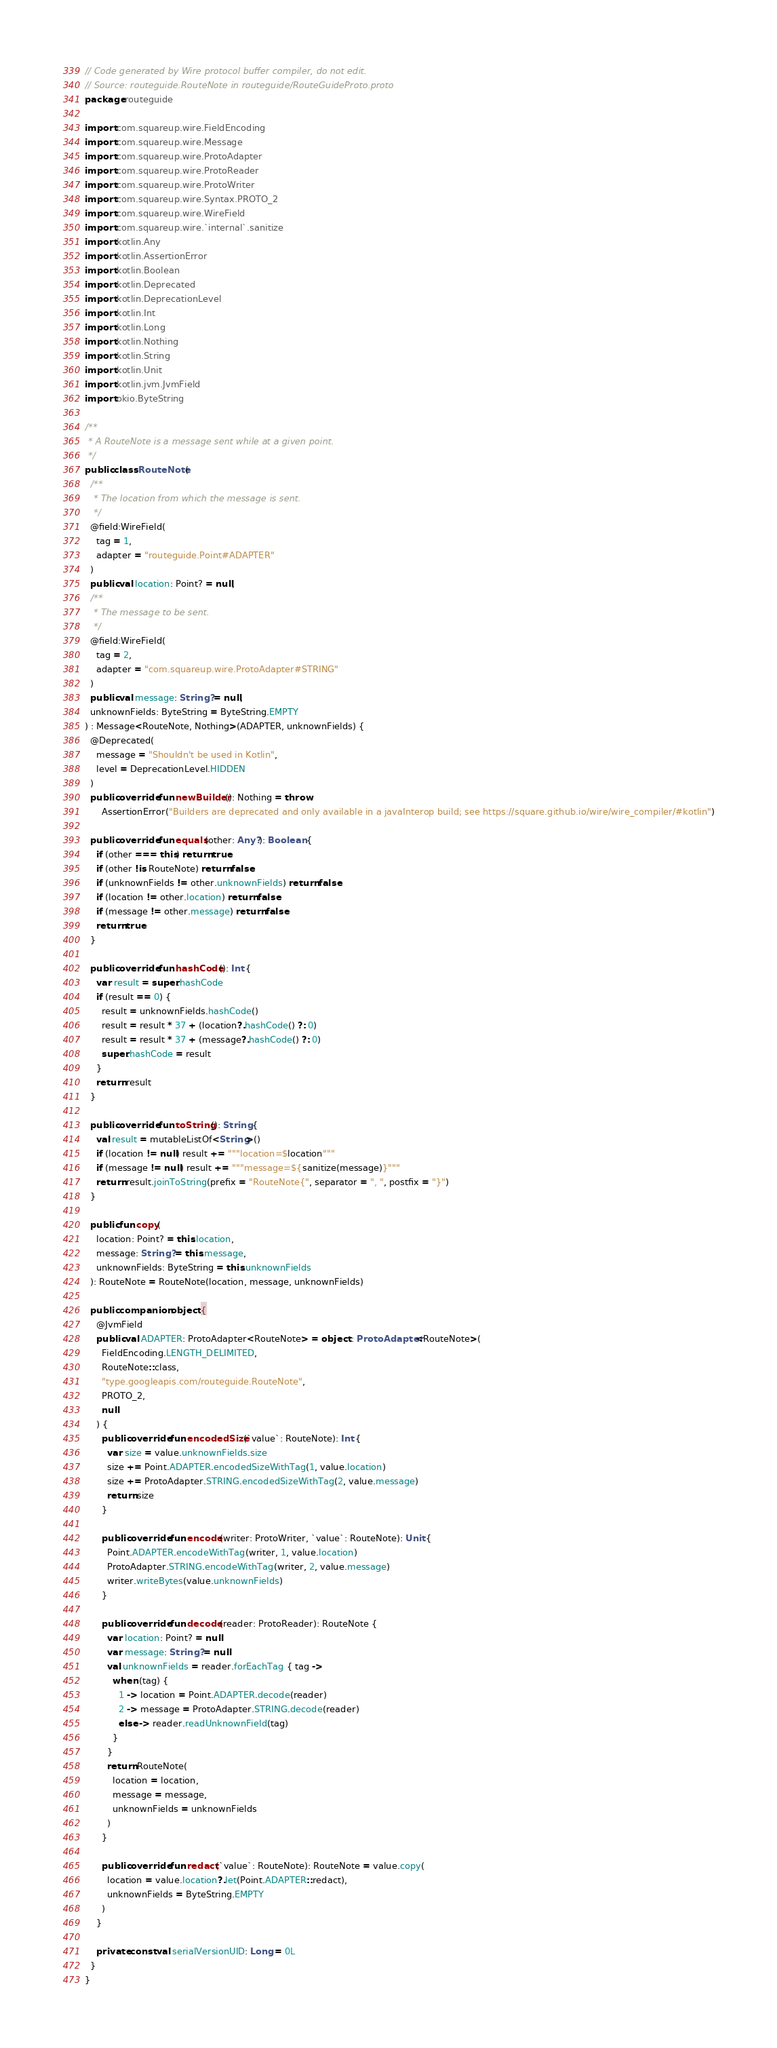<code> <loc_0><loc_0><loc_500><loc_500><_Kotlin_>// Code generated by Wire protocol buffer compiler, do not edit.
// Source: routeguide.RouteNote in routeguide/RouteGuideProto.proto
package routeguide

import com.squareup.wire.FieldEncoding
import com.squareup.wire.Message
import com.squareup.wire.ProtoAdapter
import com.squareup.wire.ProtoReader
import com.squareup.wire.ProtoWriter
import com.squareup.wire.Syntax.PROTO_2
import com.squareup.wire.WireField
import com.squareup.wire.`internal`.sanitize
import kotlin.Any
import kotlin.AssertionError
import kotlin.Boolean
import kotlin.Deprecated
import kotlin.DeprecationLevel
import kotlin.Int
import kotlin.Long
import kotlin.Nothing
import kotlin.String
import kotlin.Unit
import kotlin.jvm.JvmField
import okio.ByteString

/**
 * A RouteNote is a message sent while at a given point.
 */
public class RouteNote(
  /**
   * The location from which the message is sent.
   */
  @field:WireField(
    tag = 1,
    adapter = "routeguide.Point#ADAPTER"
  )
  public val location: Point? = null,
  /**
   * The message to be sent.
   */
  @field:WireField(
    tag = 2,
    adapter = "com.squareup.wire.ProtoAdapter#STRING"
  )
  public val message: String? = null,
  unknownFields: ByteString = ByteString.EMPTY
) : Message<RouteNote, Nothing>(ADAPTER, unknownFields) {
  @Deprecated(
    message = "Shouldn't be used in Kotlin",
    level = DeprecationLevel.HIDDEN
  )
  public override fun newBuilder(): Nothing = throw
      AssertionError("Builders are deprecated and only available in a javaInterop build; see https://square.github.io/wire/wire_compiler/#kotlin")

  public override fun equals(other: Any?): Boolean {
    if (other === this) return true
    if (other !is RouteNote) return false
    if (unknownFields != other.unknownFields) return false
    if (location != other.location) return false
    if (message != other.message) return false
    return true
  }

  public override fun hashCode(): Int {
    var result = super.hashCode
    if (result == 0) {
      result = unknownFields.hashCode()
      result = result * 37 + (location?.hashCode() ?: 0)
      result = result * 37 + (message?.hashCode() ?: 0)
      super.hashCode = result
    }
    return result
  }

  public override fun toString(): String {
    val result = mutableListOf<String>()
    if (location != null) result += """location=$location"""
    if (message != null) result += """message=${sanitize(message)}"""
    return result.joinToString(prefix = "RouteNote{", separator = ", ", postfix = "}")
  }

  public fun copy(
    location: Point? = this.location,
    message: String? = this.message,
    unknownFields: ByteString = this.unknownFields
  ): RouteNote = RouteNote(location, message, unknownFields)

  public companion object {
    @JvmField
    public val ADAPTER: ProtoAdapter<RouteNote> = object : ProtoAdapter<RouteNote>(
      FieldEncoding.LENGTH_DELIMITED, 
      RouteNote::class, 
      "type.googleapis.com/routeguide.RouteNote", 
      PROTO_2, 
      null
    ) {
      public override fun encodedSize(`value`: RouteNote): Int {
        var size = value.unknownFields.size
        size += Point.ADAPTER.encodedSizeWithTag(1, value.location)
        size += ProtoAdapter.STRING.encodedSizeWithTag(2, value.message)
        return size
      }

      public override fun encode(writer: ProtoWriter, `value`: RouteNote): Unit {
        Point.ADAPTER.encodeWithTag(writer, 1, value.location)
        ProtoAdapter.STRING.encodeWithTag(writer, 2, value.message)
        writer.writeBytes(value.unknownFields)
      }

      public override fun decode(reader: ProtoReader): RouteNote {
        var location: Point? = null
        var message: String? = null
        val unknownFields = reader.forEachTag { tag ->
          when (tag) {
            1 -> location = Point.ADAPTER.decode(reader)
            2 -> message = ProtoAdapter.STRING.decode(reader)
            else -> reader.readUnknownField(tag)
          }
        }
        return RouteNote(
          location = location,
          message = message,
          unknownFields = unknownFields
        )
      }

      public override fun redact(`value`: RouteNote): RouteNote = value.copy(
        location = value.location?.let(Point.ADAPTER::redact),
        unknownFields = ByteString.EMPTY
      )
    }

    private const val serialVersionUID: Long = 0L
  }
}
</code> 